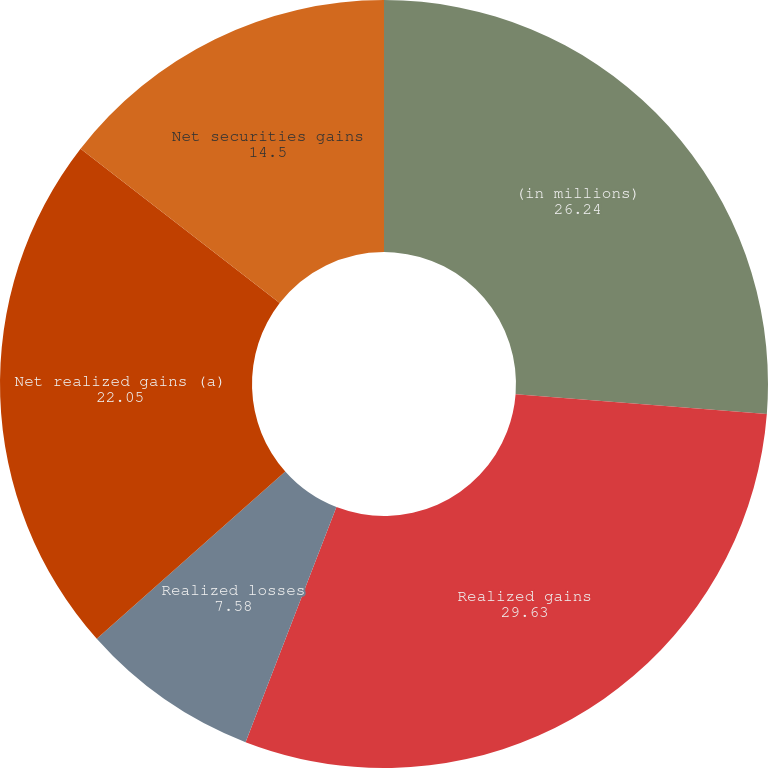Convert chart to OTSL. <chart><loc_0><loc_0><loc_500><loc_500><pie_chart><fcel>(in millions)<fcel>Realized gains<fcel>Realized losses<fcel>Net realized gains (a)<fcel>Net securities gains<nl><fcel>26.24%<fcel>29.63%<fcel>7.58%<fcel>22.05%<fcel>14.5%<nl></chart> 